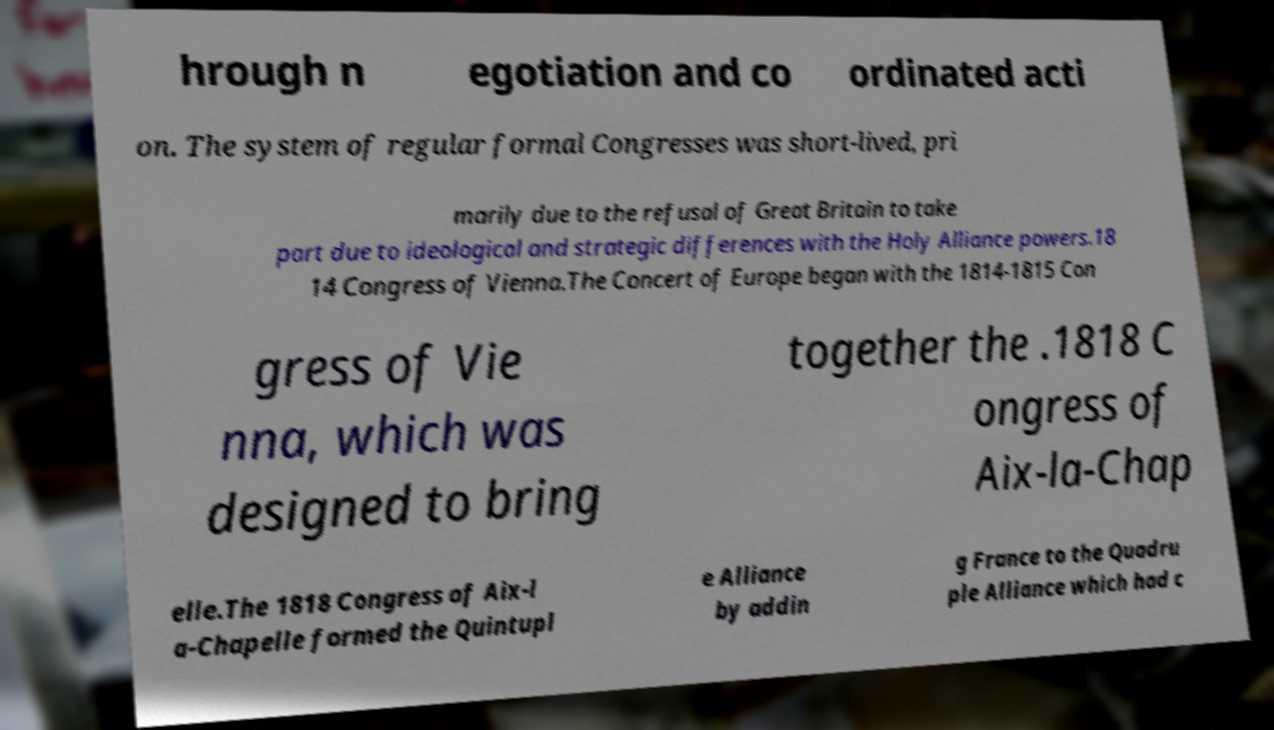Please identify and transcribe the text found in this image. hrough n egotiation and co ordinated acti on. The system of regular formal Congresses was short-lived, pri marily due to the refusal of Great Britain to take part due to ideological and strategic differences with the Holy Alliance powers.18 14 Congress of Vienna.The Concert of Europe began with the 1814-1815 Con gress of Vie nna, which was designed to bring together the .1818 C ongress of Aix-la-Chap elle.The 1818 Congress of Aix-l a-Chapelle formed the Quintupl e Alliance by addin g France to the Quadru ple Alliance which had c 